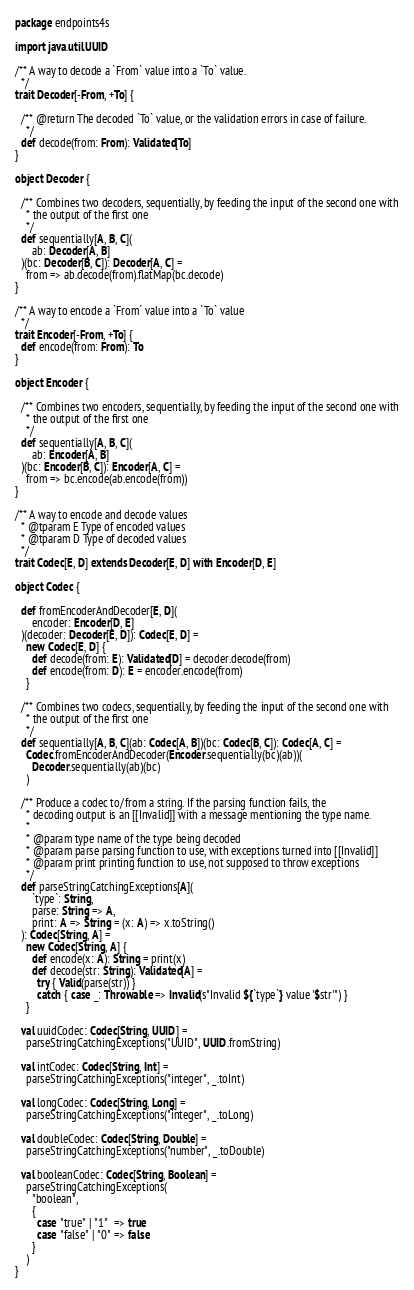Convert code to text. <code><loc_0><loc_0><loc_500><loc_500><_Scala_>package endpoints4s

import java.util.UUID

/** A way to decode a `From` value into a `To` value.
  */
trait Decoder[-From, +To] {

  /** @return The decoded `To` value, or the validation errors in case of failure.
    */
  def decode(from: From): Validated[To]
}

object Decoder {

  /** Combines two decoders, sequentially, by feeding the input of the second one with
    * the output of the first one
    */
  def sequentially[A, B, C](
      ab: Decoder[A, B]
  )(bc: Decoder[B, C]): Decoder[A, C] =
    from => ab.decode(from).flatMap(bc.decode)
}

/** A way to encode a `From` value into a `To` value
  */
trait Encoder[-From, +To] {
  def encode(from: From): To
}

object Encoder {

  /** Combines two encoders, sequentially, by feeding the input of the second one with
    * the output of the first one
    */
  def sequentially[A, B, C](
      ab: Encoder[A, B]
  )(bc: Encoder[B, C]): Encoder[A, C] =
    from => bc.encode(ab.encode(from))
}

/** A way to encode and decode values
  * @tparam E Type of encoded values
  * @tparam D Type of decoded values
  */
trait Codec[E, D] extends Decoder[E, D] with Encoder[D, E]

object Codec {

  def fromEncoderAndDecoder[E, D](
      encoder: Encoder[D, E]
  )(decoder: Decoder[E, D]): Codec[E, D] =
    new Codec[E, D] {
      def decode(from: E): Validated[D] = decoder.decode(from)
      def encode(from: D): E = encoder.encode(from)
    }

  /** Combines two codecs, sequentially, by feeding the input of the second one with
    * the output of the first one
    */
  def sequentially[A, B, C](ab: Codec[A, B])(bc: Codec[B, C]): Codec[A, C] =
    Codec.fromEncoderAndDecoder(Encoder.sequentially(bc)(ab))(
      Decoder.sequentially(ab)(bc)
    )

  /** Produce a codec to/from a string. If the parsing function fails, the
    * decoding output is an [[Invalid]] with a message mentioning the type name.
    *
    * @param type name of the type being decoded
    * @param parse parsing function to use, with exceptions turned into [[Invalid]]
    * @param print printing function to use, not supposed to throw exceptions
    */
  def parseStringCatchingExceptions[A](
      `type`: String,
      parse: String => A,
      print: A => String = (x: A) => x.toString()
  ): Codec[String, A] =
    new Codec[String, A] {
      def encode(x: A): String = print(x)
      def decode(str: String): Validated[A] =
        try { Valid(parse(str)) }
        catch { case _: Throwable => Invalid(s"Invalid ${`type`} value '$str'") }
    }

  val uuidCodec: Codec[String, UUID] =
    parseStringCatchingExceptions("UUID", UUID.fromString)

  val intCodec: Codec[String, Int] =
    parseStringCatchingExceptions("integer", _.toInt)

  val longCodec: Codec[String, Long] =
    parseStringCatchingExceptions("integer", _.toLong)

  val doubleCodec: Codec[String, Double] =
    parseStringCatchingExceptions("number", _.toDouble)

  val booleanCodec: Codec[String, Boolean] =
    parseStringCatchingExceptions(
      "boolean",
      {
        case "true" | "1"  => true
        case "false" | "0" => false
      }
    )
}
</code> 